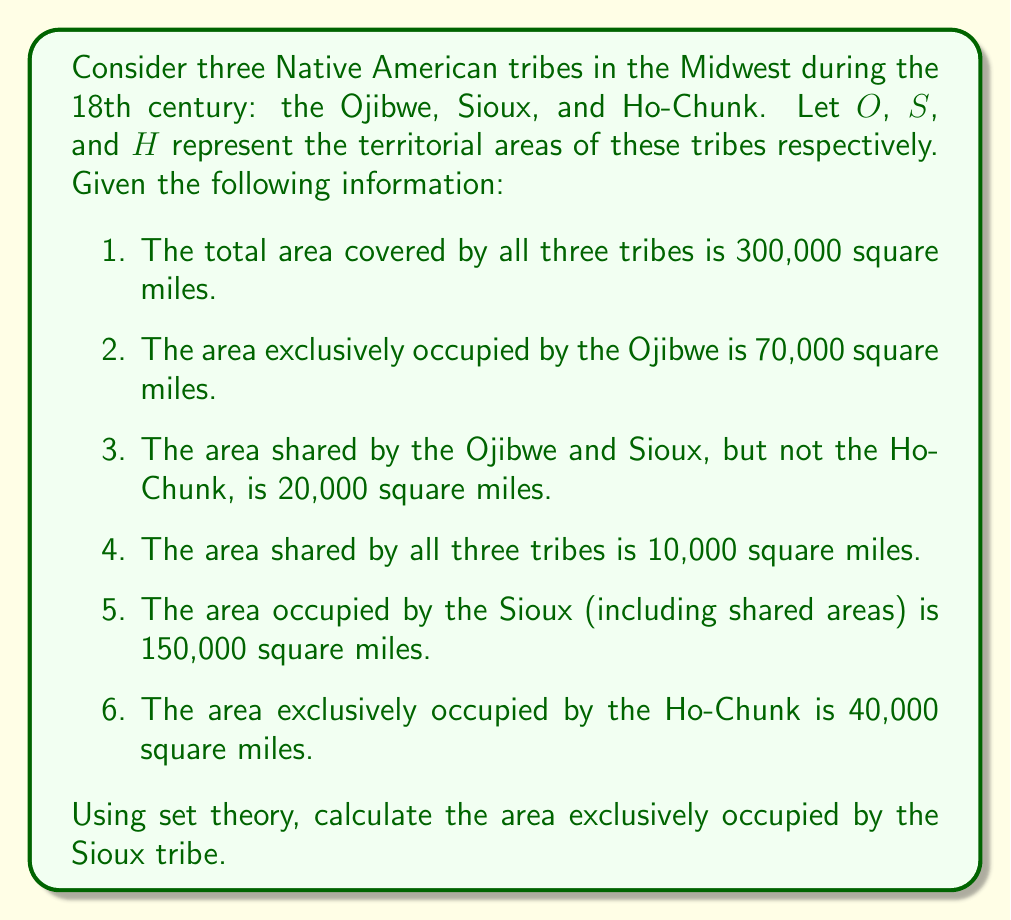What is the answer to this math problem? To solve this problem, we'll use the principle of inclusion-exclusion and set theory concepts. Let's break it down step by step:

1. First, let's define our sets:
   $O$ = Ojibwe territory
   $S$ = Sioux territory
   $H$ = Ho-Chunk territory

2. We're given the following information:
   $|O \cup S \cup H| = 300,000$ (total area)
   $|O \setminus (S \cup H)| = 70,000$ (exclusive Ojibwe area)
   $|(O \cap S) \setminus H| = 20,000$ (area shared by Ojibwe and Sioux, not Ho-Chunk)
   $|O \cap S \cap H| = 10,000$ (area shared by all three)
   $|S| = 150,000$ (total Sioux area)
   $|H \setminus (O \cup S)| = 40,000$ (exclusive Ho-Chunk area)

3. We need to find $|S \setminus (O \cup H)|$, which is the area exclusively occupied by the Sioux.

4. Using the principle of inclusion-exclusion:
   $|O \cup S \cup H| = |O| + |S| + |H| - |O \cap S| - |O \cap H| - |S \cap H| + |O \cap S \cap H|$

5. We can rearrange this to solve for $|S \cap H|$:
   $|S \cap H| = |O| + |S| + |H| - |O \cup S \cup H| - |O \cap S| - |O \cap H| + |O \cap S \cap H|$

6. We know $|S| = 150,000$, but we need to calculate $|O|$ and $|H|$:
   $|O| = 70,000 + 20,000 + |O \cap H \setminus S| + 10,000$
   $|H| = 40,000 + |O \cap H \setminus S| + |S \cap H \setminus O| + 10,000$

7. We can substitute these into the equation from step 5, along with the known values:
   $|S \cap H| = (70,000 + 20,000 + |O \cap H \setminus S| + 10,000) + 150,000 + (40,000 + |O \cap H \setminus S| + |S \cap H \setminus O| + 10,000) - 300,000 - (20,000 + 10,000) - (|O \cap H \setminus S| + 10,000) + 10,000$

8. Simplifying:
   $|S \cap H| = |S \cap H \setminus O| + 20,000$

9. Now, we can use the fact that $|S| = 150,000$ to find the exclusive Sioux area:
   $150,000 = |S \setminus (O \cup H)| + (20,000 + 10,000) + (|S \cap H \setminus O| + 20,000)$

10. Simplifying:
    $150,000 = |S \setminus (O \cup H)| + 50,000 + |S \cap H \setminus O|$

11. Rearranging:
    $|S \setminus (O \cup H)| = 100,000 - |S \cap H \setminus O|$

Therefore, the area exclusively occupied by the Sioux is 100,000 square miles minus the area shared by Sioux and Ho-Chunk but not Ojibwe.
Answer: The area exclusively occupied by the Sioux tribe is $100,000 - |S \cap H \setminus O|$ square miles, where $|S \cap H \setminus O|$ represents the area shared by Sioux and Ho-Chunk but not Ojibwe. 